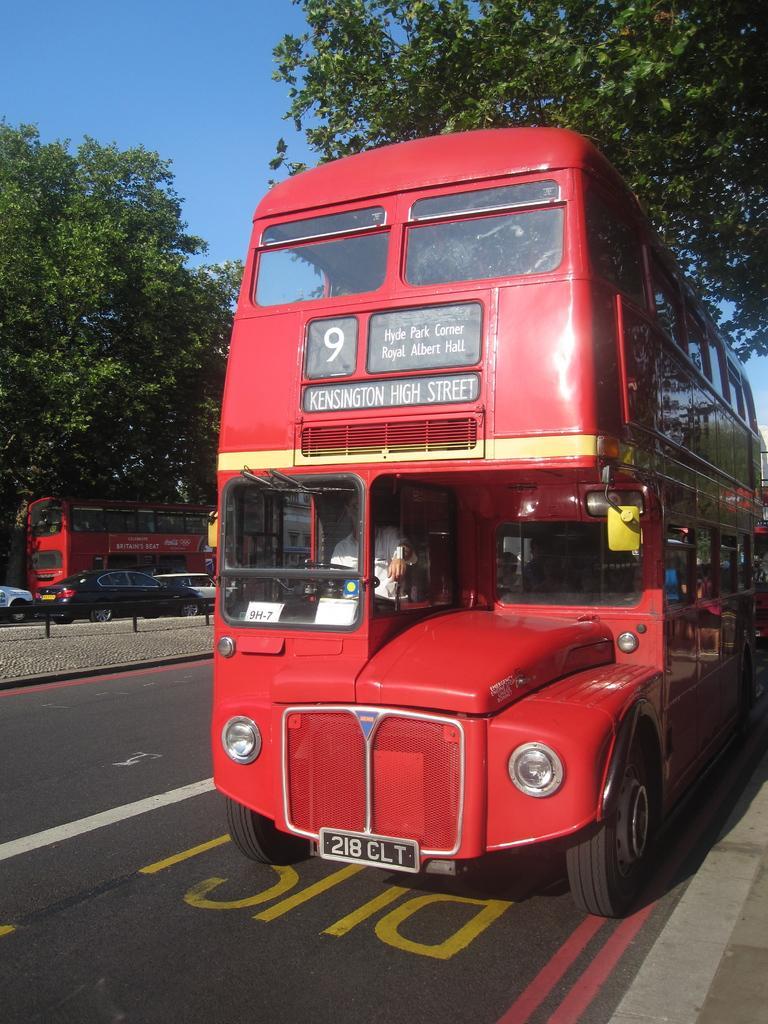How would you summarize this image in a sentence or two? In the foreground of the picture I can see a red color double Decker bus on the road and there is a man in the bus. There are trees on the left side and the right side as well. I can see three cars and another red color bus on the road. There are clouds in the sky. 